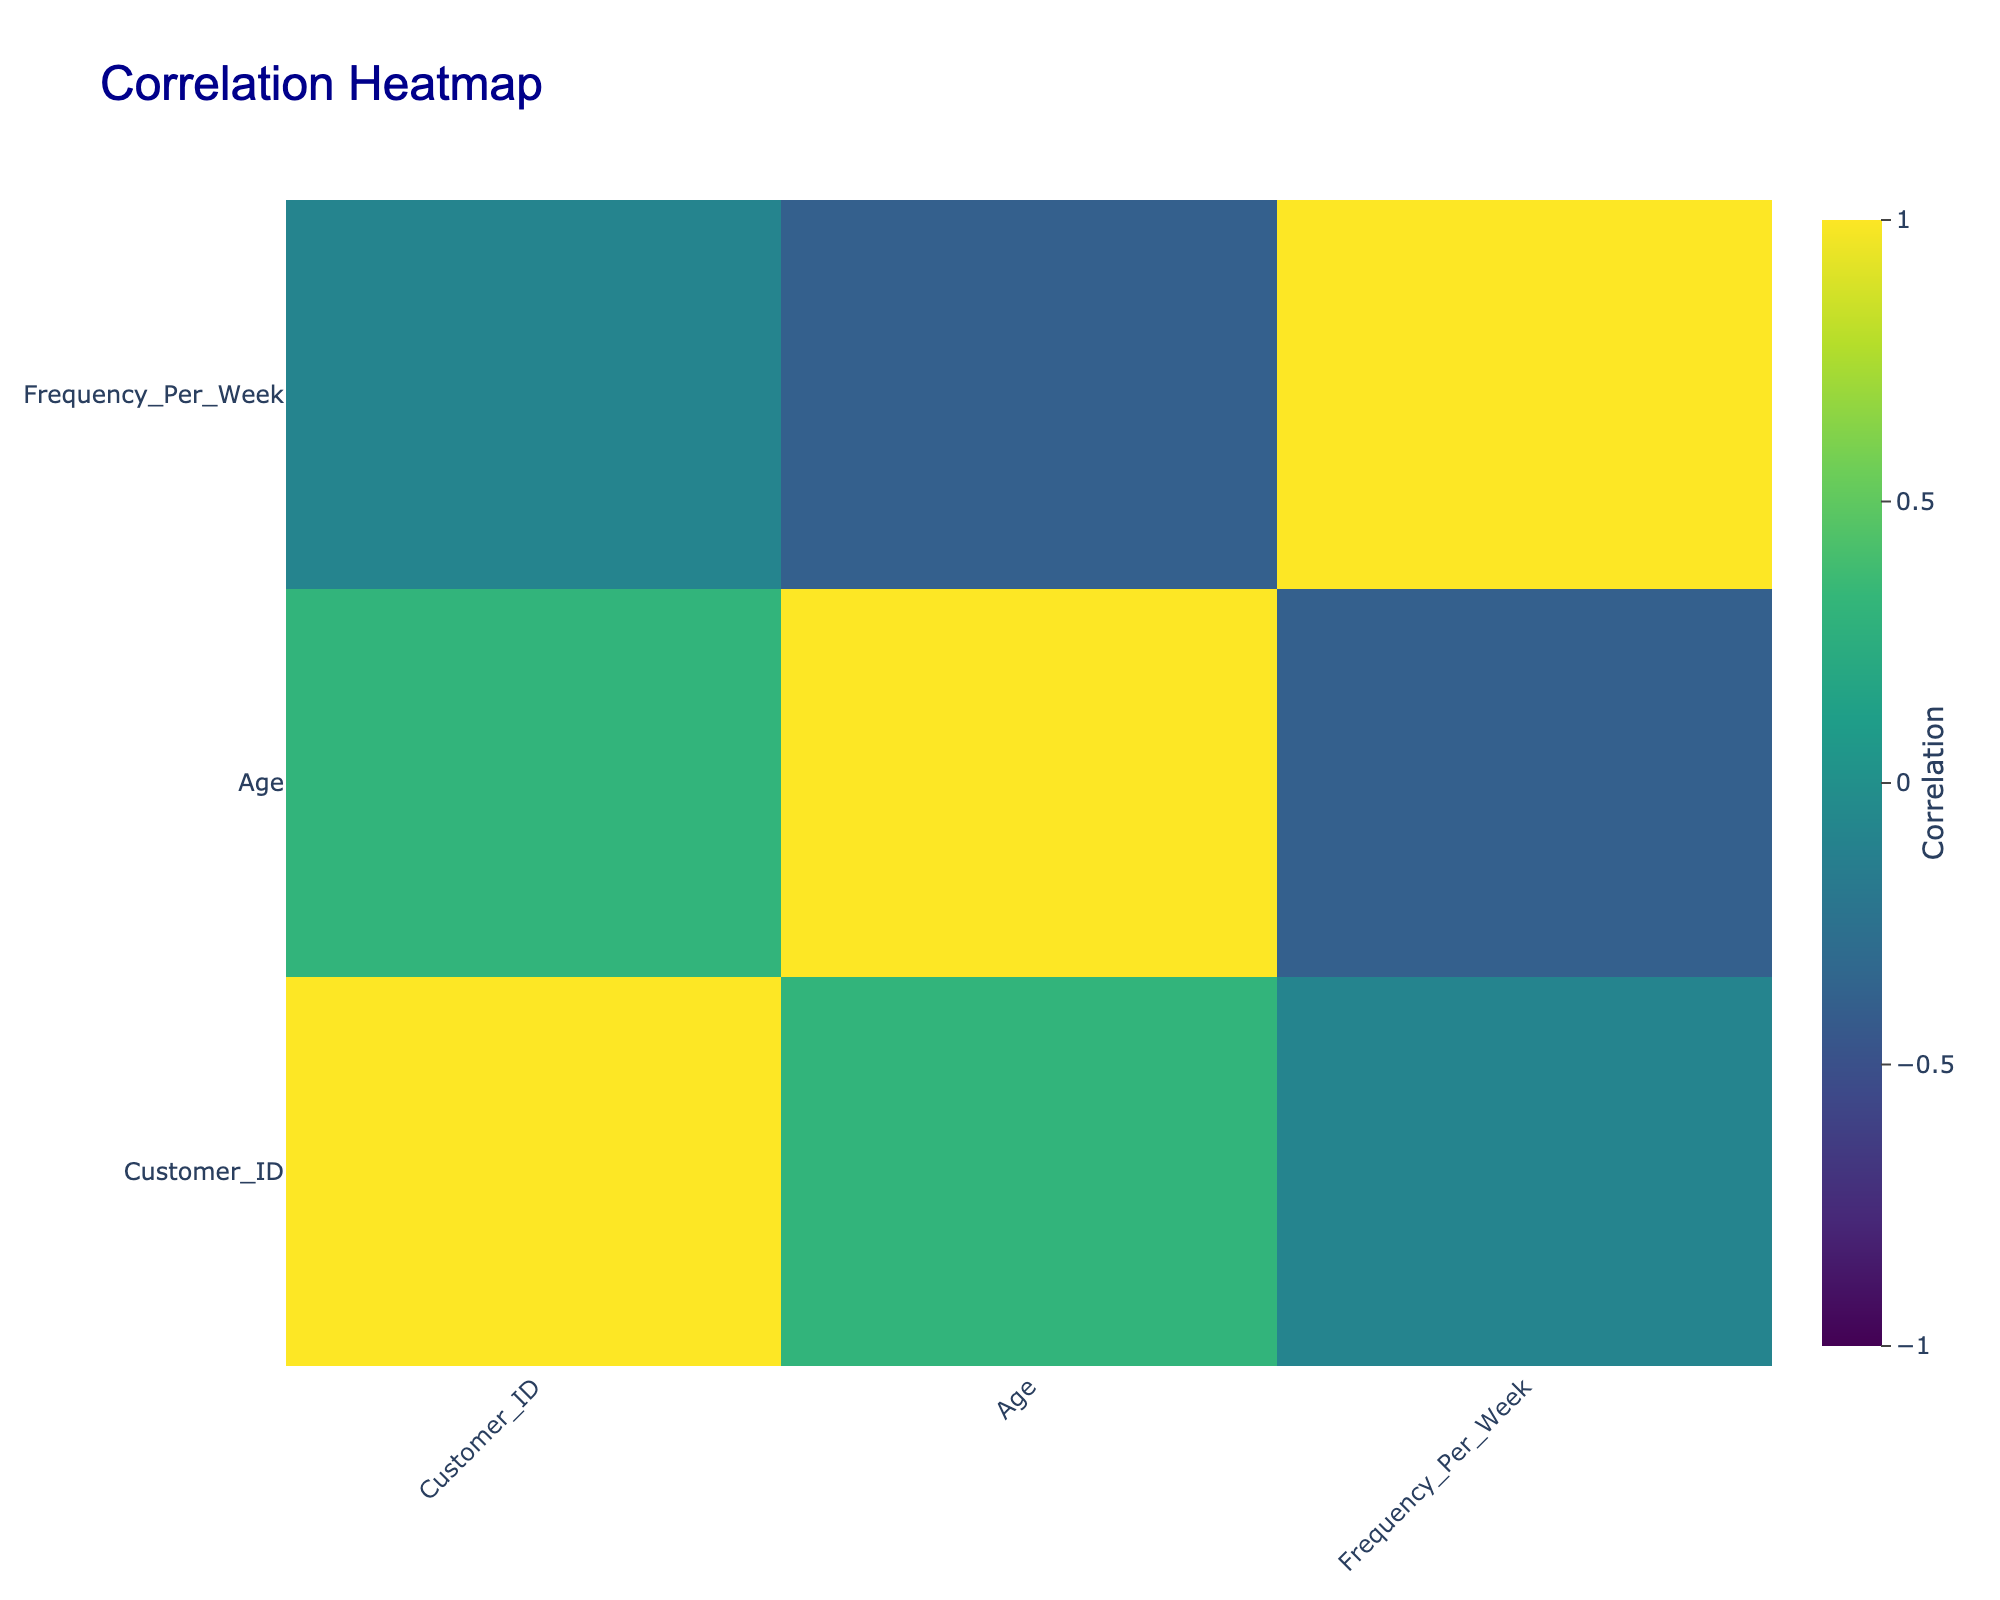What is the frequency of the beverage choice for vegan customers? There are 4 vegan customers. Their beverage choices and frequencies per week are: Chai Latte (3), Matcha Latte (1), Macchiato (4), and Herbal Tea (2). Therefore, the values are 3, 1, 4, and 2 which sum up to 10. The average frequency is 10/4 = 2.5.
Answer: 2.5 What is the beverage choice of the youngest customer? The youngest customer is customer 3, who is 19 years old. Their beverage choice is Chai Latte.
Answer: Chai Latte Are there more male or female customers in this data? There are 5 female and 5 male customers. We can determine this by counting the occurrences of each gender in the Gender column. Since both counts are equal, there is no majority.
Answer: Equal What is the average frequency of customers who prefer coffee? The customers who chose coffee are customers 2, 4, 8, and 9 with frequencies of 2, 4, 3, and 5 respectively. To find the average, first sum these frequencies: 2 + 4 + 3 + 5 = 14. There are 4 coffee drinkers, so the average is 14/4 = 3.5.
Answer: 3.5 Do any customers with a gluten-free dietary trend also choose a latte? The gluten-free customer is customer 9, who chose Cappuccino. We check the Beverage Choice of all gluten-free customers. Since none of them chose a latte, the answer is no.
Answer: No Which coffee type is chosen most frequently? The coffee types chosen by customers include Coffee, Herbal Tea, and Matcha. Their respective frequencies are: Coffee (2 times), Herbal Tea (2 times), and Matcha (1 time). The highest frequency among these choices is Coffee, appearing twice.
Answer: Coffee What is the correlation between being vegan and the choice of beverages? To find the correlation, we can analyze the frequencies and the dietary trends. The correlation value between the vegan column and beverage choice indicates a relation; if the value is positive, there is a tendency for vegan customers to prefer specific beverages. Thus, the relationship is analyzed through the correlation matrix which would indicate this directly.
Answer: Correlation value (need visual) How many customers chose matcha products, and what is their overall frequency? The only customer who chose matcha is customer 6, and their frequency is 1. Therefore, the total number of customers choosing matcha is 1 and the overall frequency is also 1.
Answer: 1 customer, 1 frequency What is the total frequency of beverage choices for omnivores? The omnivore customer is customer 5, who chooses a smoothie with a frequency of 2. Since they are the only omnivore, the total frequency is simply 2.
Answer: 2 